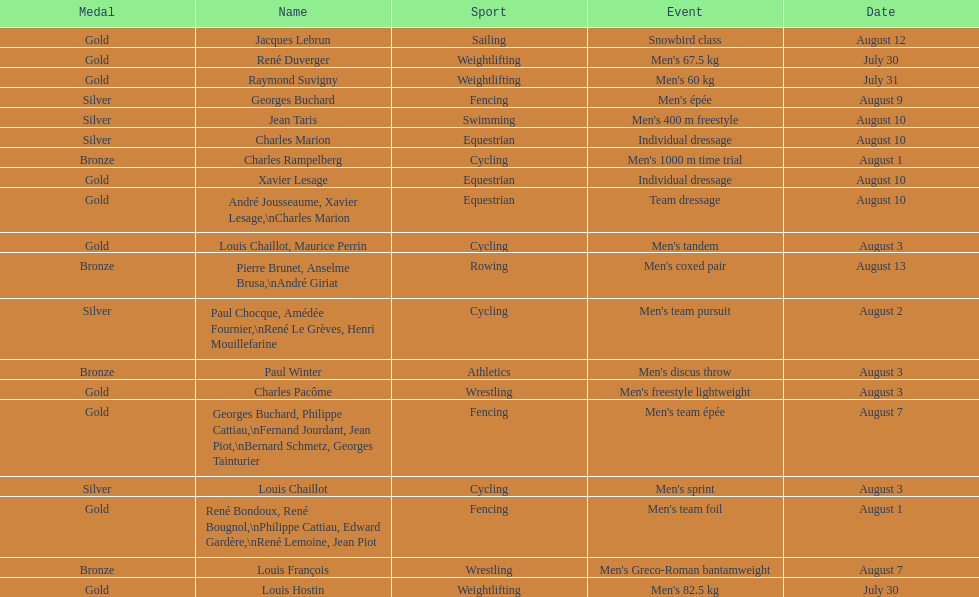Was there more gold medals won than silver? Yes. 